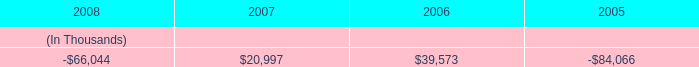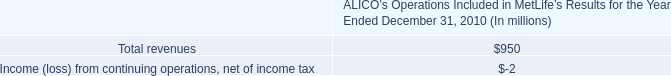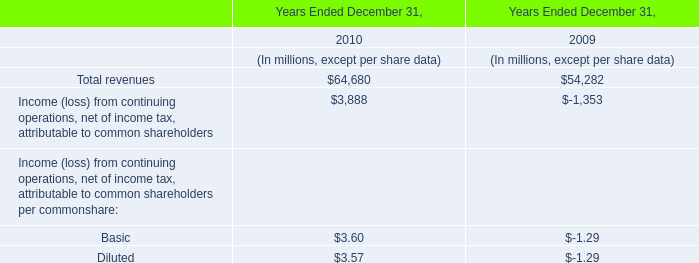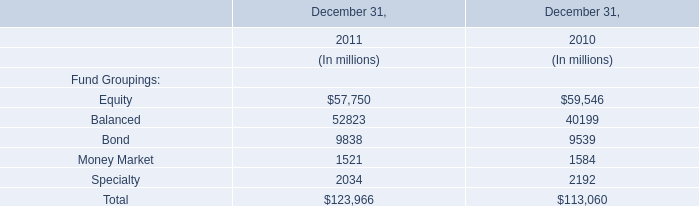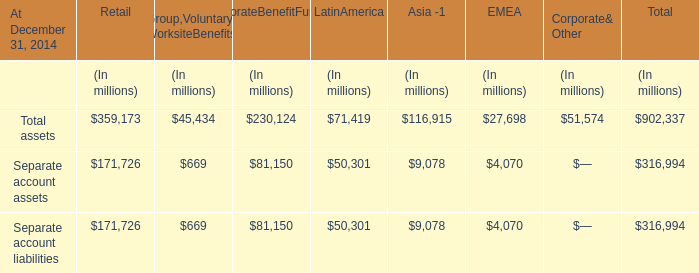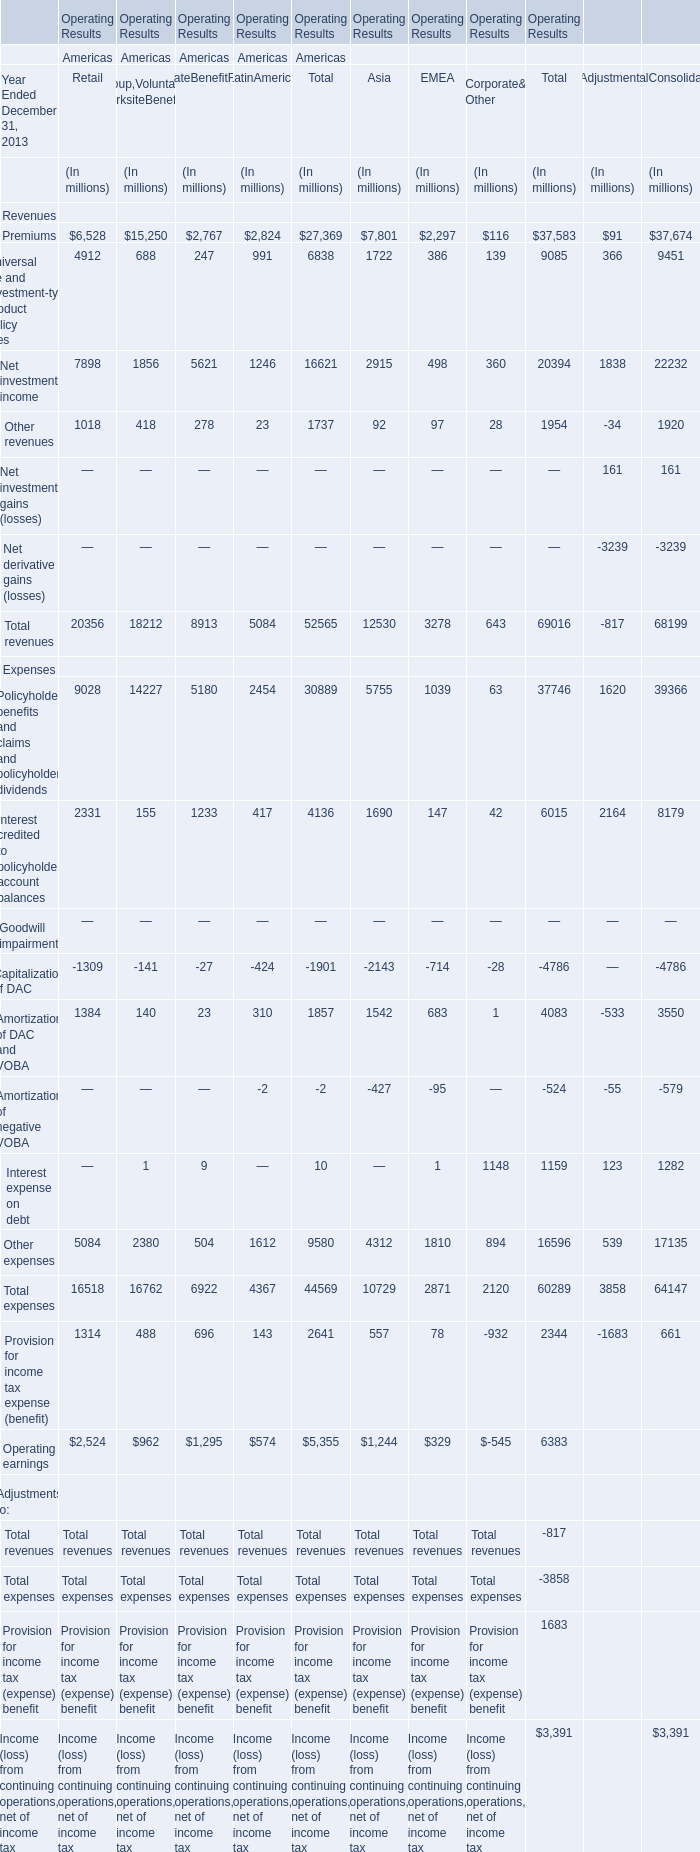Does the value of Total assets in 2014 for Group,Voluntary& WorksiteBenefits greater than that in Retail? 
Answer: no. 